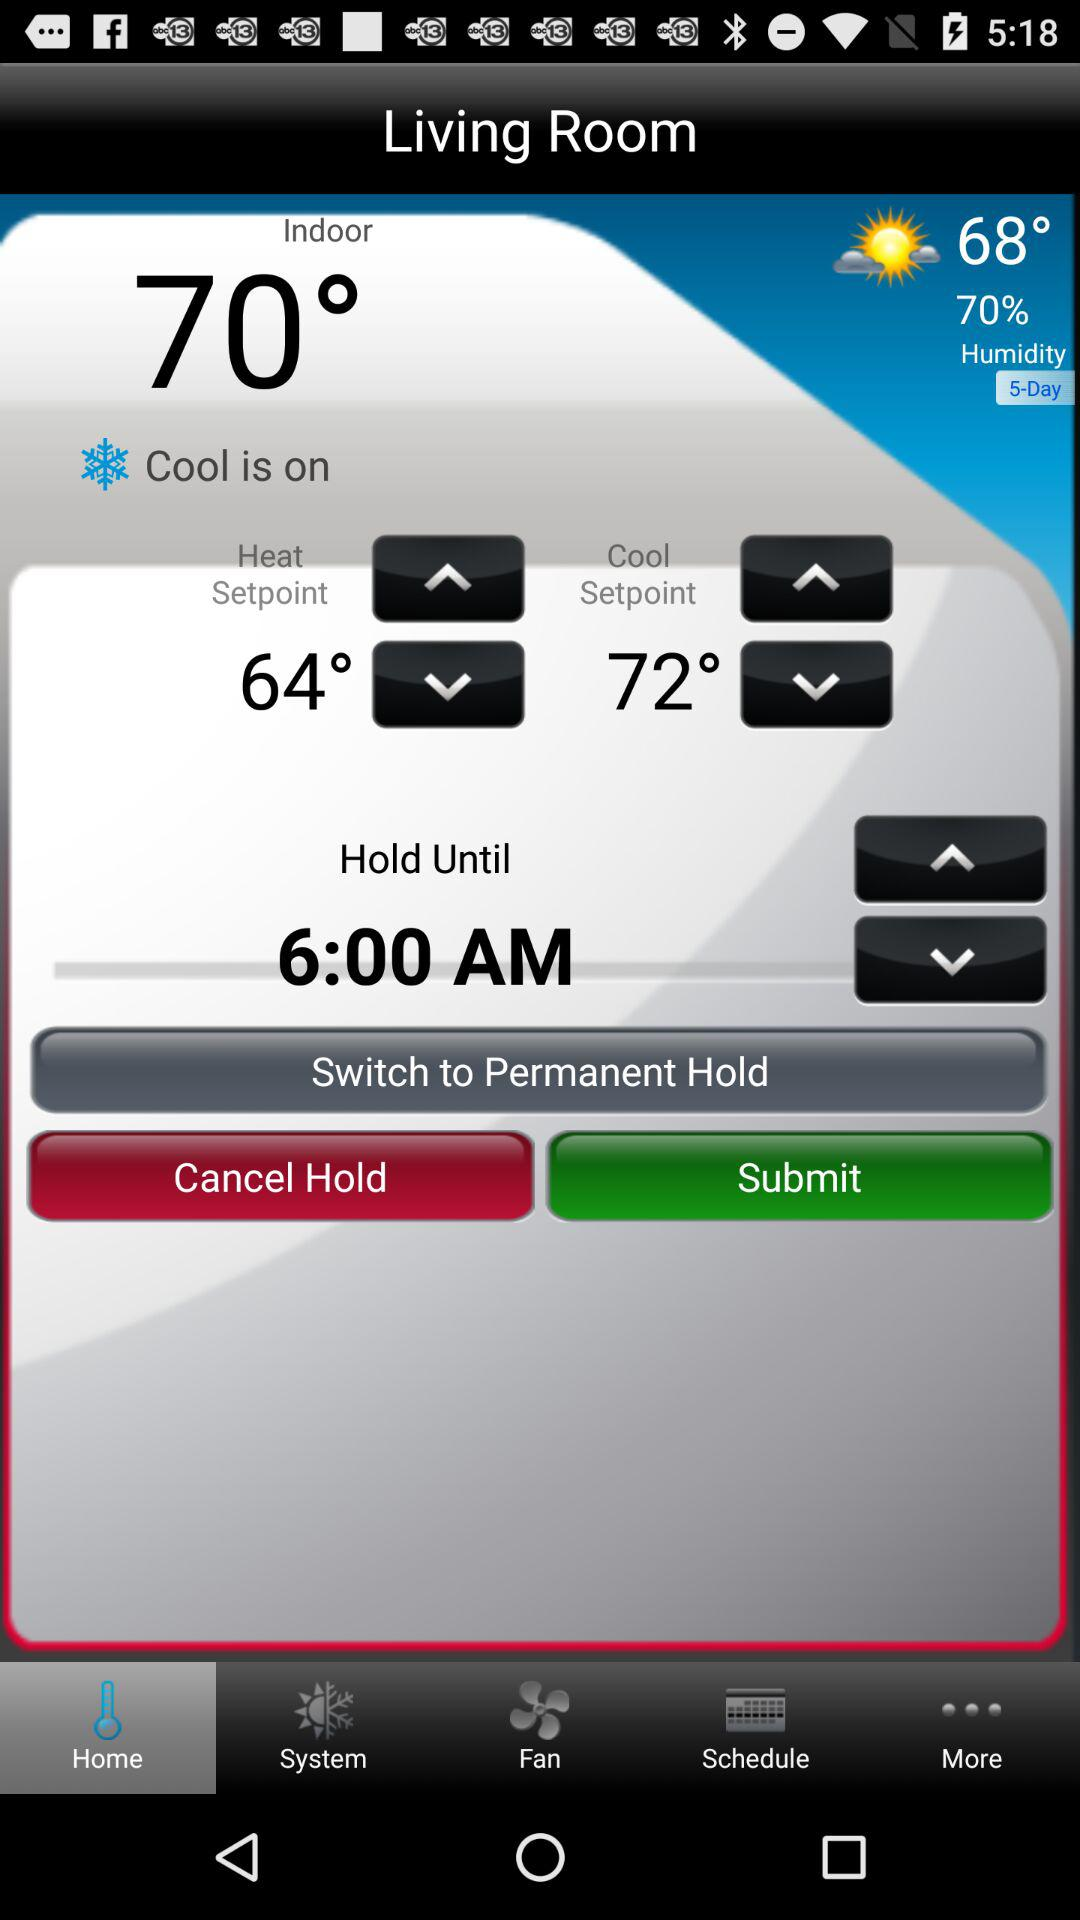Which tab am I using? You are using the tab "Home". 